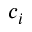Convert formula to latex. <formula><loc_0><loc_0><loc_500><loc_500>c _ { i }</formula> 